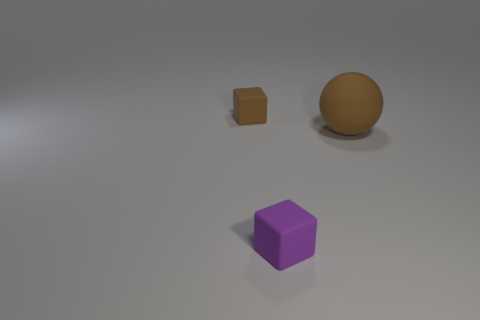Are there any other things that have the same size as the rubber sphere?
Offer a very short reply. No. What is the tiny object in front of the rubber sphere made of?
Provide a succinct answer. Rubber. What number of big spheres have the same material as the brown cube?
Your answer should be very brief. 1. There is a rubber object that is right of the tiny brown rubber object and behind the tiny purple matte thing; what shape is it?
Your answer should be compact. Sphere. How many things are brown rubber objects that are to the left of the large brown matte sphere or things to the left of the big brown object?
Make the answer very short. 2. Are there the same number of purple matte cubes on the left side of the purple rubber block and big rubber objects that are to the right of the big brown rubber thing?
Provide a succinct answer. Yes. The brown thing that is in front of the small cube on the left side of the purple rubber block is what shape?
Offer a terse response. Sphere. Is there another thing that has the same shape as the purple matte thing?
Provide a succinct answer. Yes. How many tiny green matte cylinders are there?
Keep it short and to the point. 0. Are there any purple matte blocks that have the same size as the brown rubber cube?
Make the answer very short. Yes. 